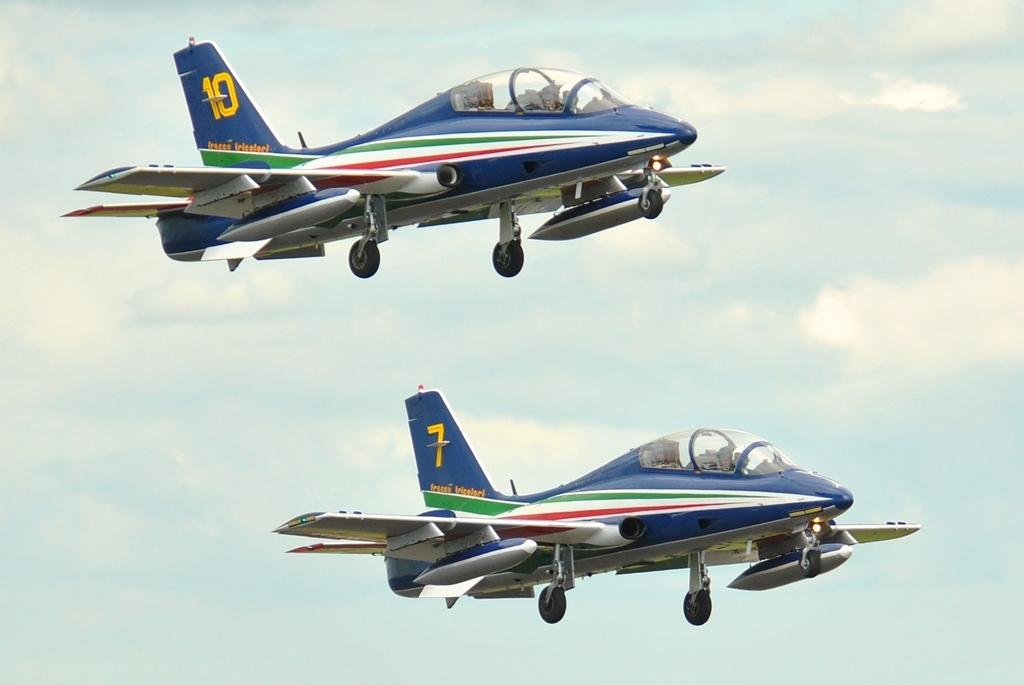What is the main subject of the image? The main subject of the image is airplanes. Can you describe the background of the image? In the background of the image, there are clouds in the sky. What caption is written on the parcel in the image? There is no parcel present in the image, so there is no caption to describe. 